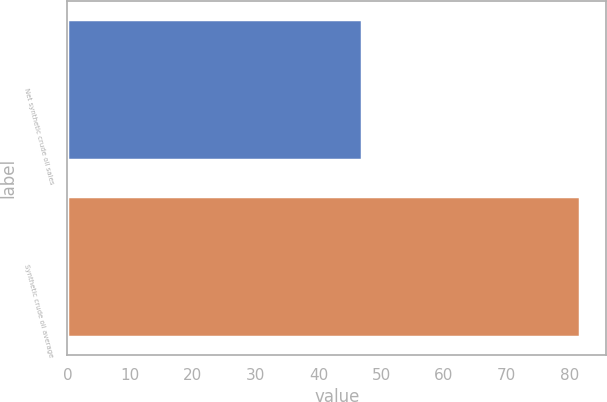Convert chart. <chart><loc_0><loc_0><loc_500><loc_500><bar_chart><fcel>Net synthetic crude oil sales<fcel>Synthetic crude oil average<nl><fcel>47<fcel>81.72<nl></chart> 